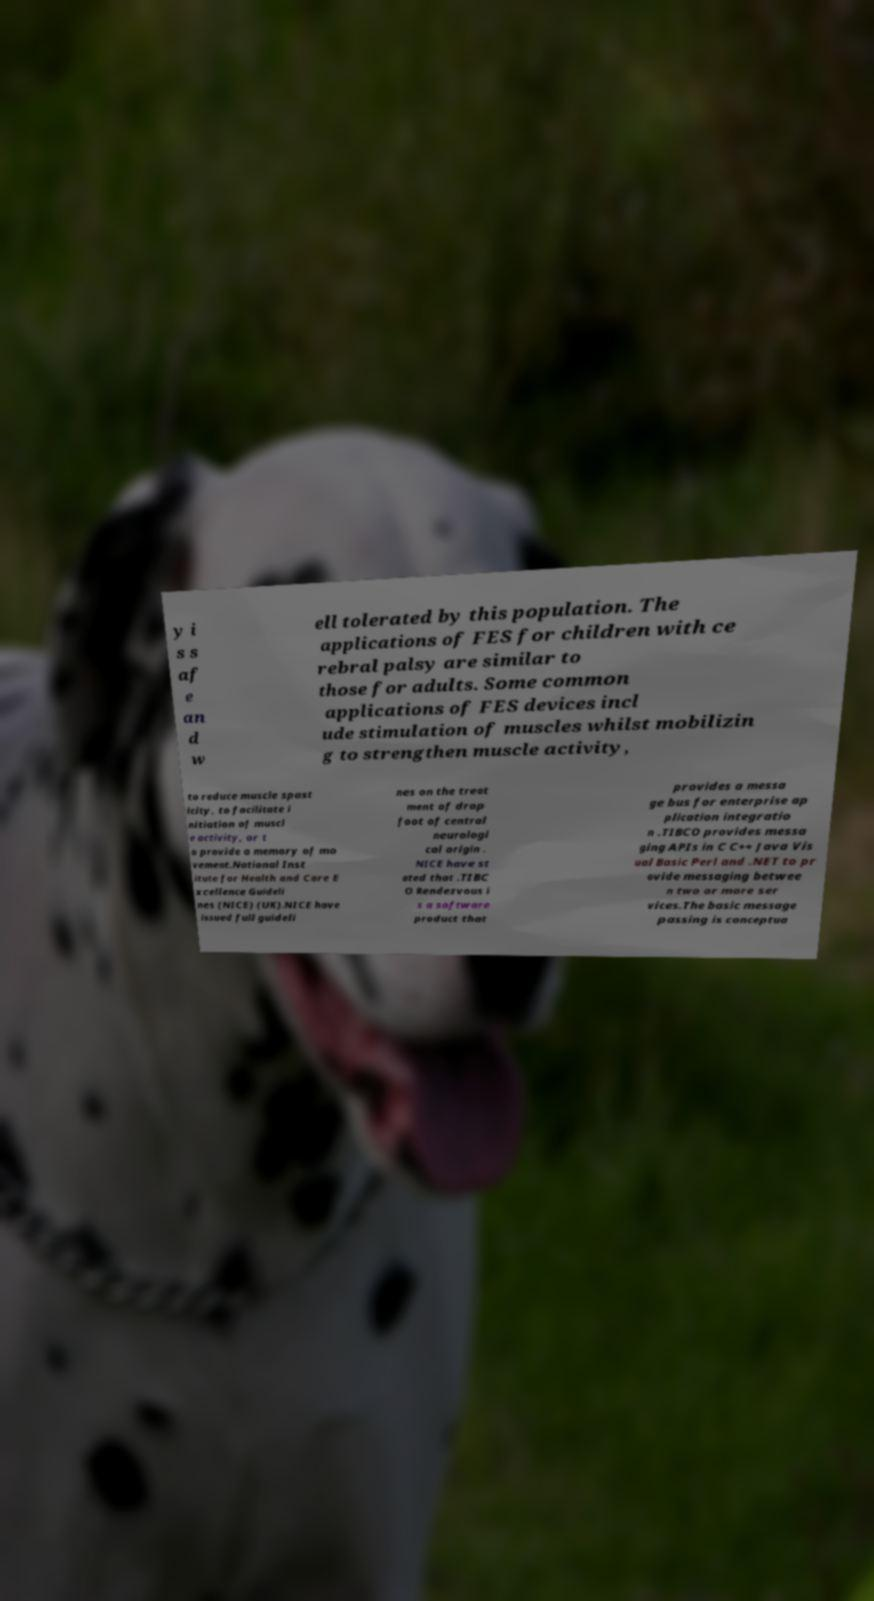Can you accurately transcribe the text from the provided image for me? y i s s af e an d w ell tolerated by this population. The applications of FES for children with ce rebral palsy are similar to those for adults. Some common applications of FES devices incl ude stimulation of muscles whilst mobilizin g to strengthen muscle activity, to reduce muscle spast icity, to facilitate i nitiation of muscl e activity, or t o provide a memory of mo vement.National Inst itute for Health and Care E xcellence Guideli nes (NICE) (UK).NICE have issued full guideli nes on the treat ment of drop foot of central neurologi cal origin . NICE have st ated that .TIBC O Rendezvous i s a software product that provides a messa ge bus for enterprise ap plication integratio n .TIBCO provides messa ging APIs in C C++ Java Vis ual Basic Perl and .NET to pr ovide messaging betwee n two or more ser vices.The basic message passing is conceptua 